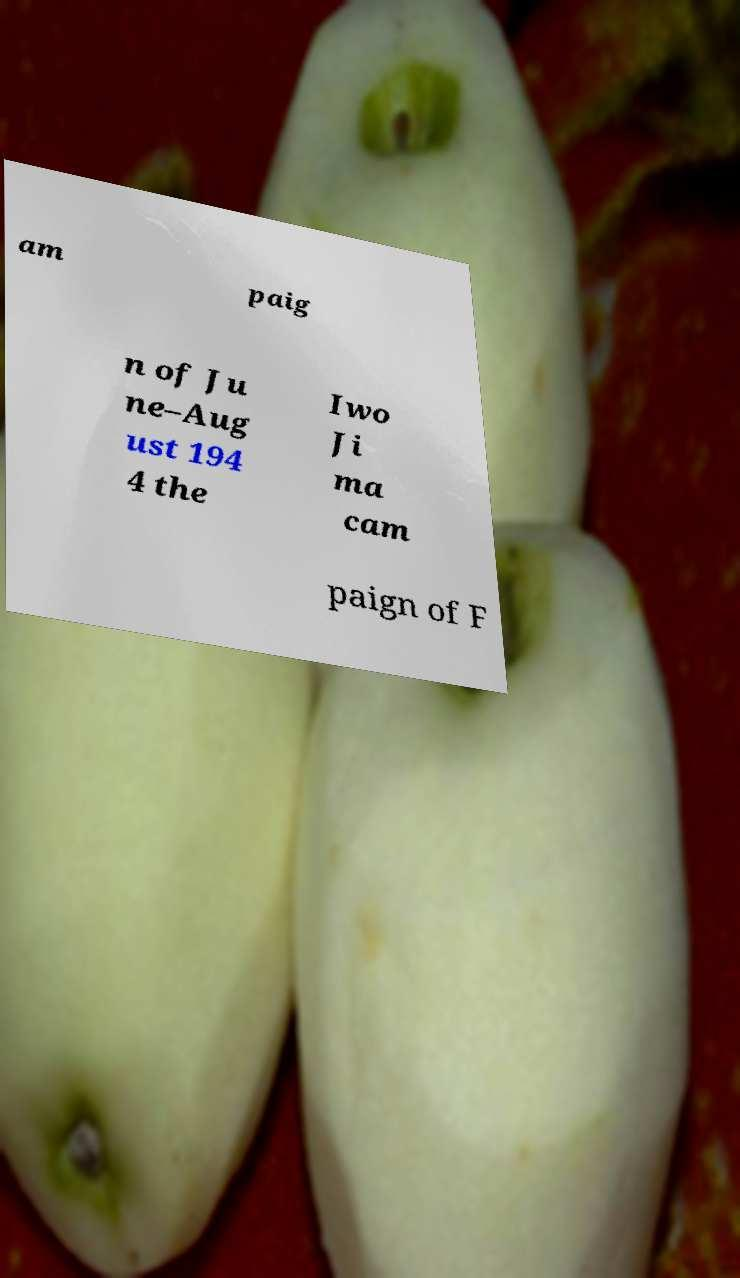What messages or text are displayed in this image? I need them in a readable, typed format. am paig n of Ju ne–Aug ust 194 4 the Iwo Ji ma cam paign of F 